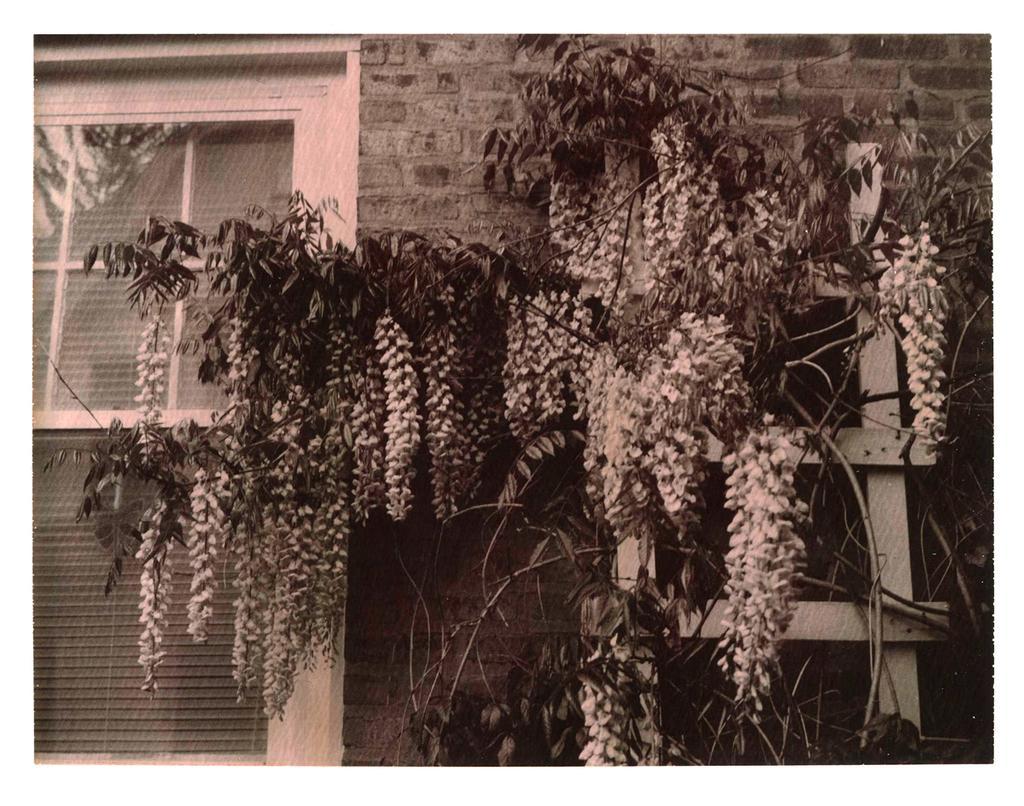Can you describe this image briefly? This is a black and white picture. Here, we see trees. Behind that, we see a building which is made up of bricks and we even see a white color window. 